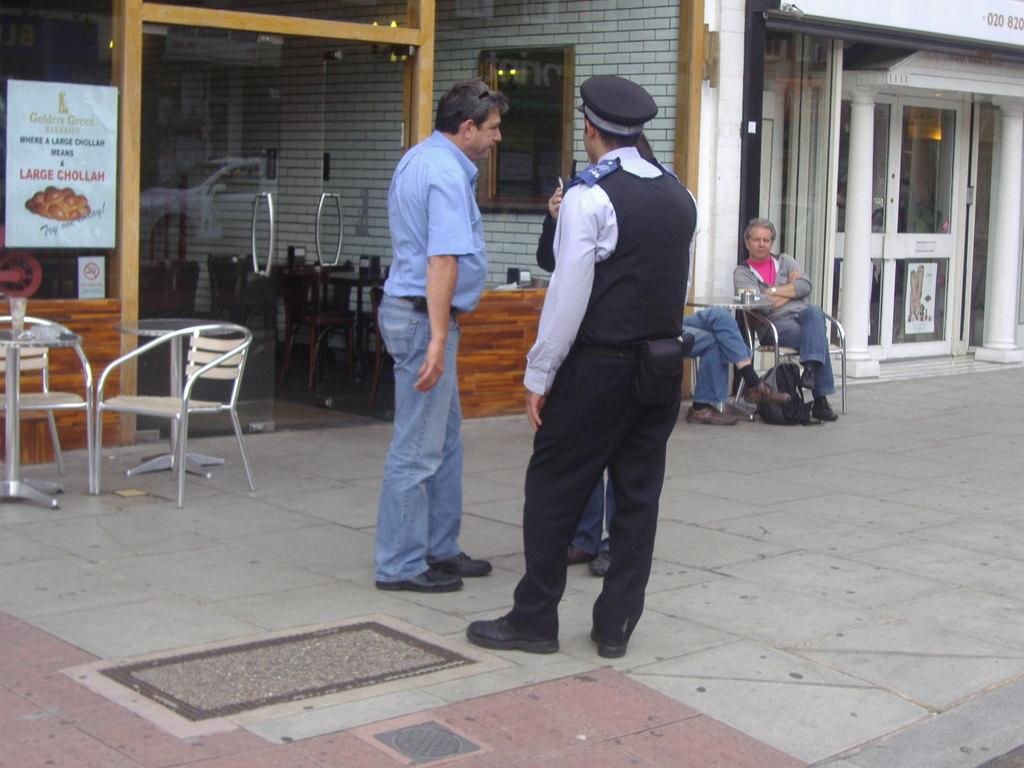How many people are in the image? There are three persons in the image. What objects are present for the people to sit on? There are chairs in the image. What type of door can be seen in the image? There is a glass door in the image. What type of cart is being used to transport the chairs in the image? There is no cart present in the image; the chairs are stationary. What can be seen inside the can in the image? There is no can present in the image. 